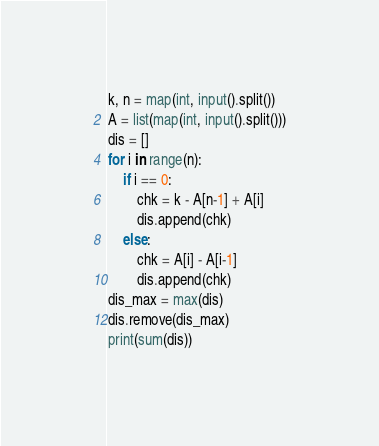Convert code to text. <code><loc_0><loc_0><loc_500><loc_500><_Python_>k, n = map(int, input().split())
A = list(map(int, input().split()))
dis = []
for i in range(n):
    if i == 0:
        chk = k - A[n-1] + A[i]
        dis.append(chk)
    else:
        chk = A[i] - A[i-1]
        dis.append(chk)
dis_max = max(dis)
dis.remove(dis_max)
print(sum(dis))</code> 